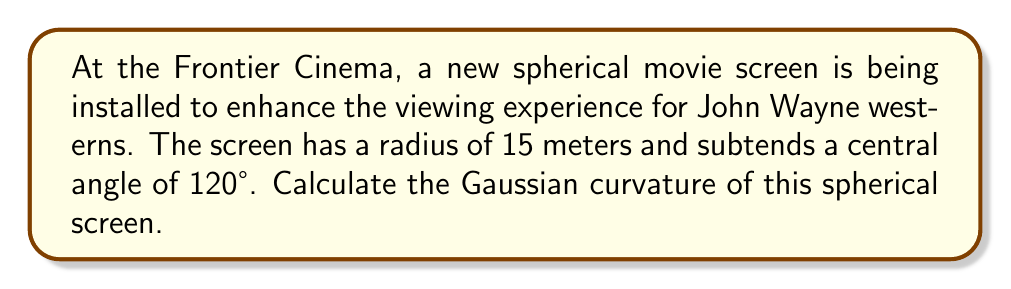Provide a solution to this math problem. Let's approach this step-by-step:

1. Recall that for a sphere, the Gaussian curvature $K$ is constant and equal to the inverse of the square of the radius:

   $$K = \frac{1}{R^2}$$

   where $R$ is the radius of the sphere.

2. We are given that the radius of the spherical screen is 15 meters. Let's substitute this into our formula:

   $$K = \frac{1}{(15\text{ m})^2}$$

3. Simplify:
   
   $$K = \frac{1}{225\text{ m}^2}$$

4. This can be further simplified to:

   $$K = 0.004444...\text{ m}^{-2}$$

Note: The central angle of 120° mentioned in the question doesn't affect the Gaussian curvature calculation, as curvature is constant over the entire sphere. However, it would be relevant for calculating the surface area of the screen, which isn't asked for in this problem.
Answer: $\frac{1}{225}\text{ m}^{-2}$ or approximately $0.004444\text{ m}^{-2}$ 